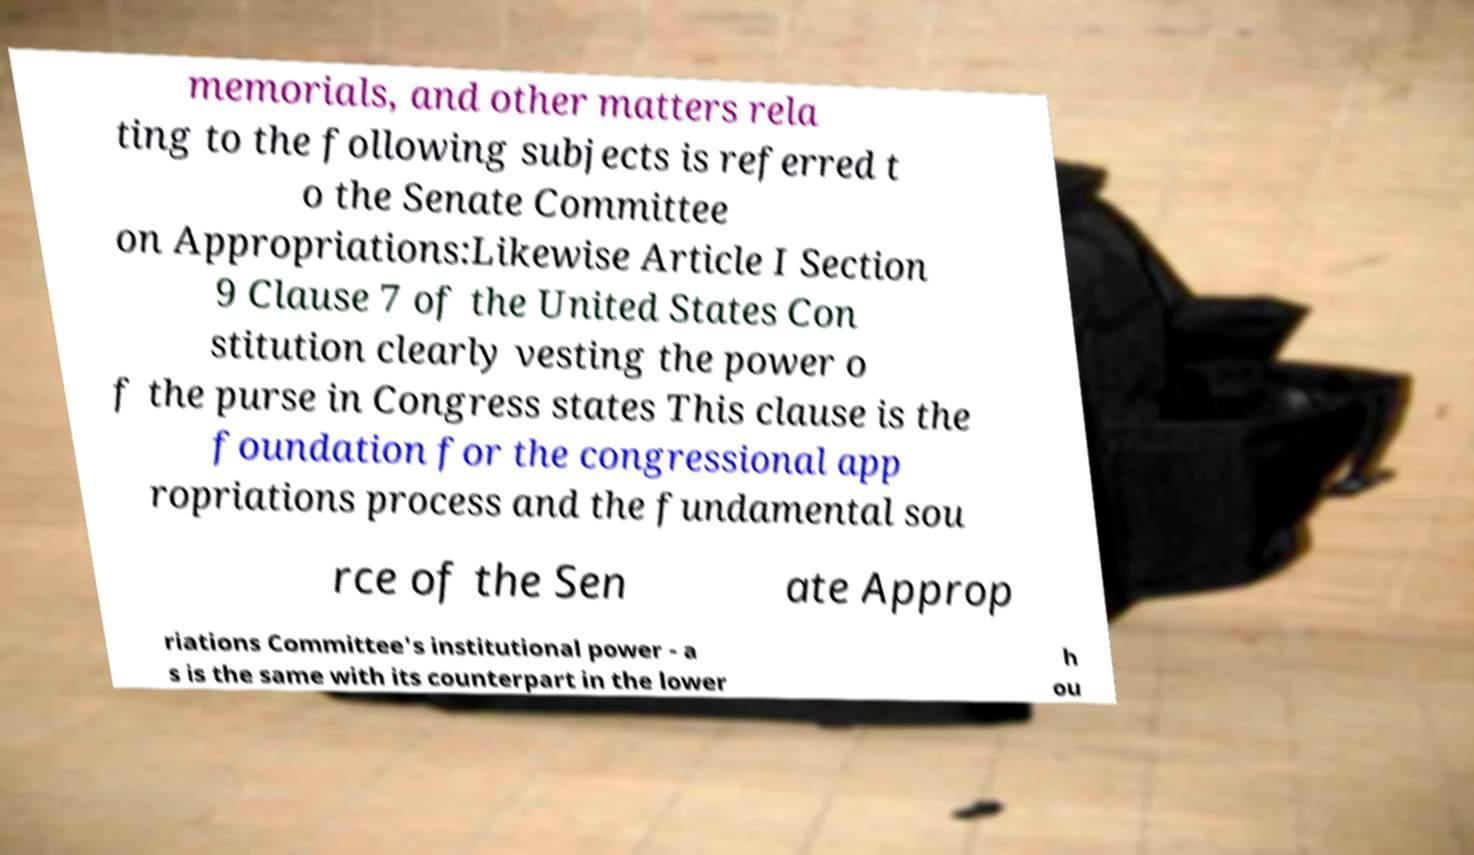Could you extract and type out the text from this image? memorials, and other matters rela ting to the following subjects is referred t o the Senate Committee on Appropriations:Likewise Article I Section 9 Clause 7 of the United States Con stitution clearly vesting the power o f the purse in Congress states This clause is the foundation for the congressional app ropriations process and the fundamental sou rce of the Sen ate Approp riations Committee's institutional power - a s is the same with its counterpart in the lower h ou 